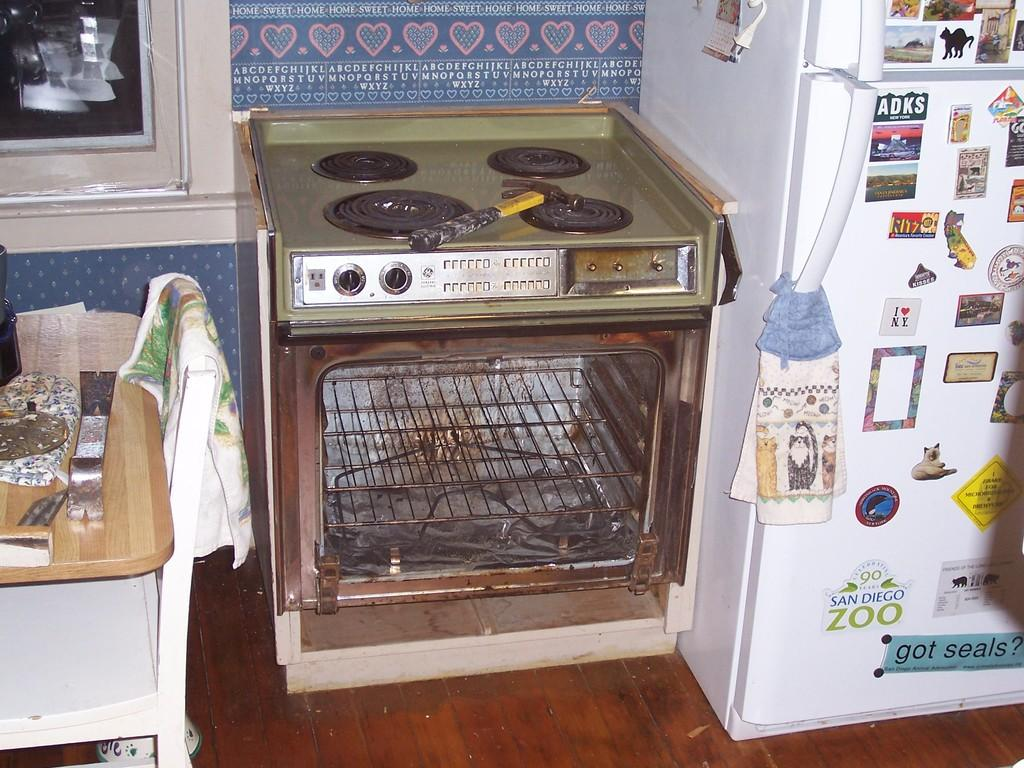Provide a one-sentence caption for the provided image. someone's broken messy GE stove with the refrigerator next to it having advertisements on it from ADKS, San Diego Zoo and Ritz. 